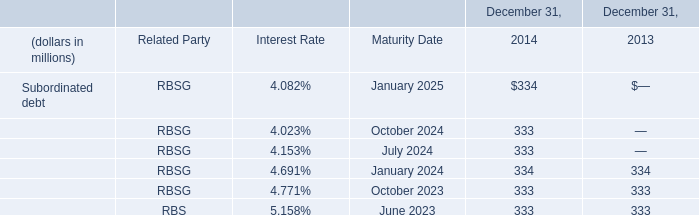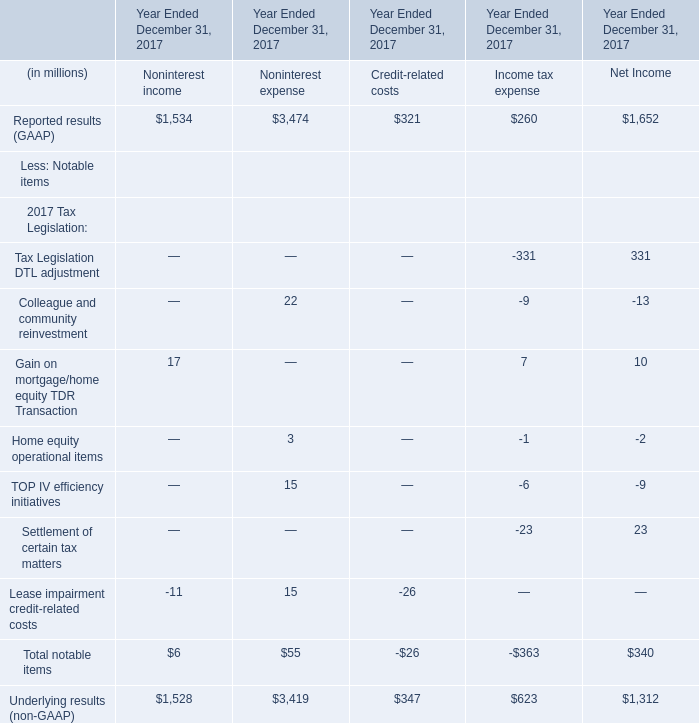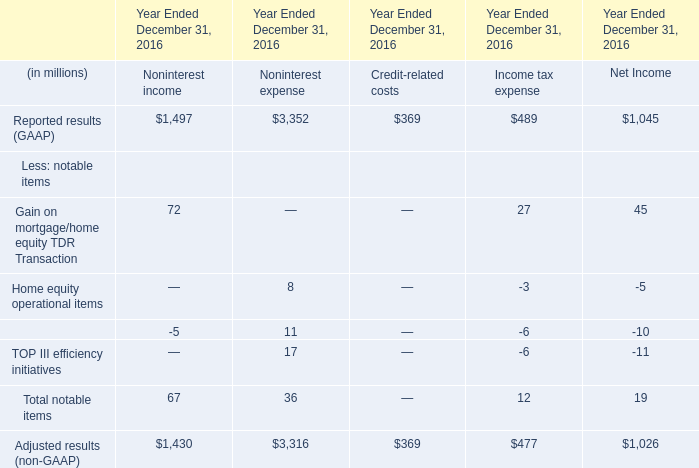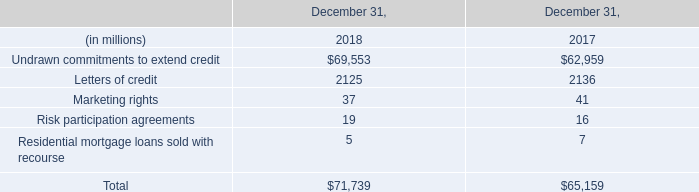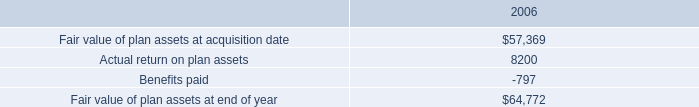what is the percent increase in the fair value of plant asset after the acquisition date? 
Computations: ((64772 - 57369) / 57369)
Answer: 0.12904. 